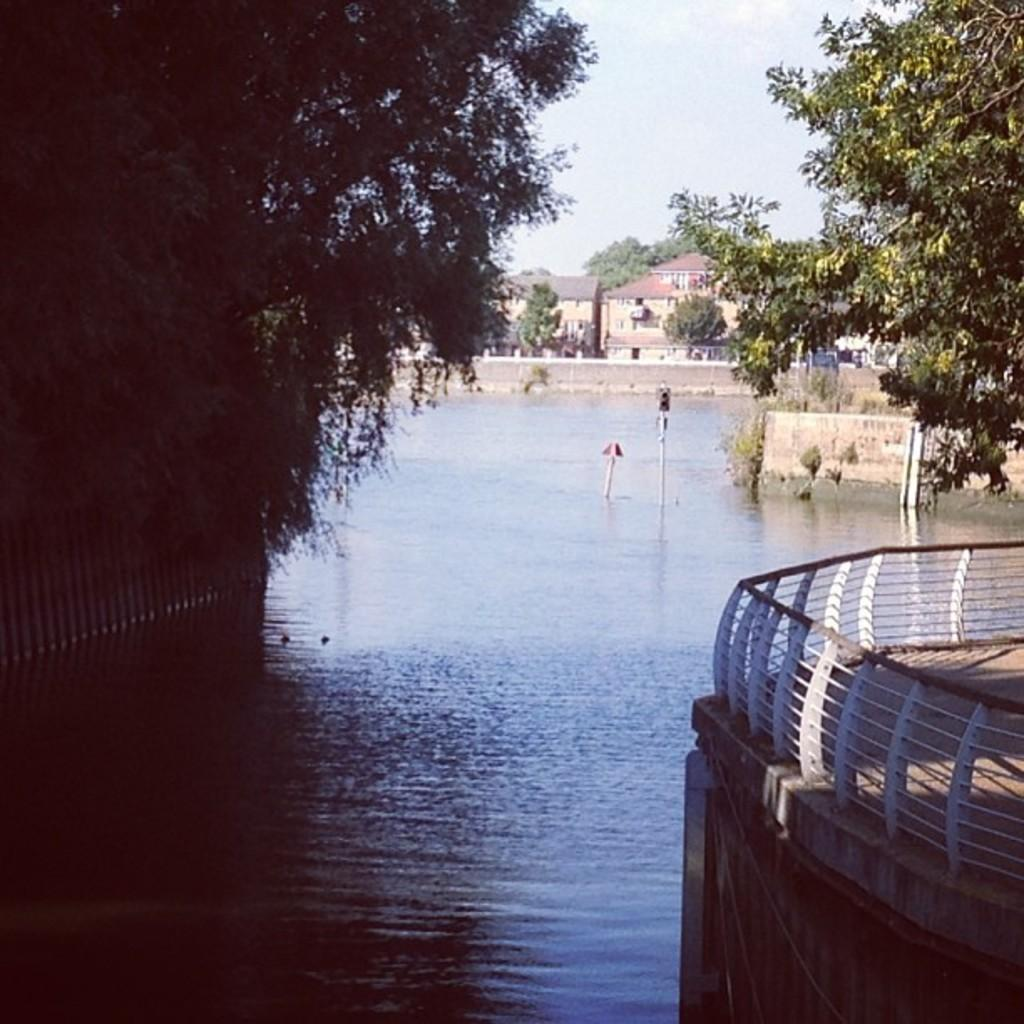What type of structure can be seen in the image? There is a building in the image. What other architectural feature is present in the image? There is a wall in the image. What natural element is visible in the image? There is water visible in the image. Can you describe any other objects in the image? There is a pole, trees, and a fencing rod in the image. What can be seen in the sky in the image? The sky is visible at the top of the image. What type of pipe is being used by the team on the playground in the image? There is no pipe, team, or playground present in the image. 